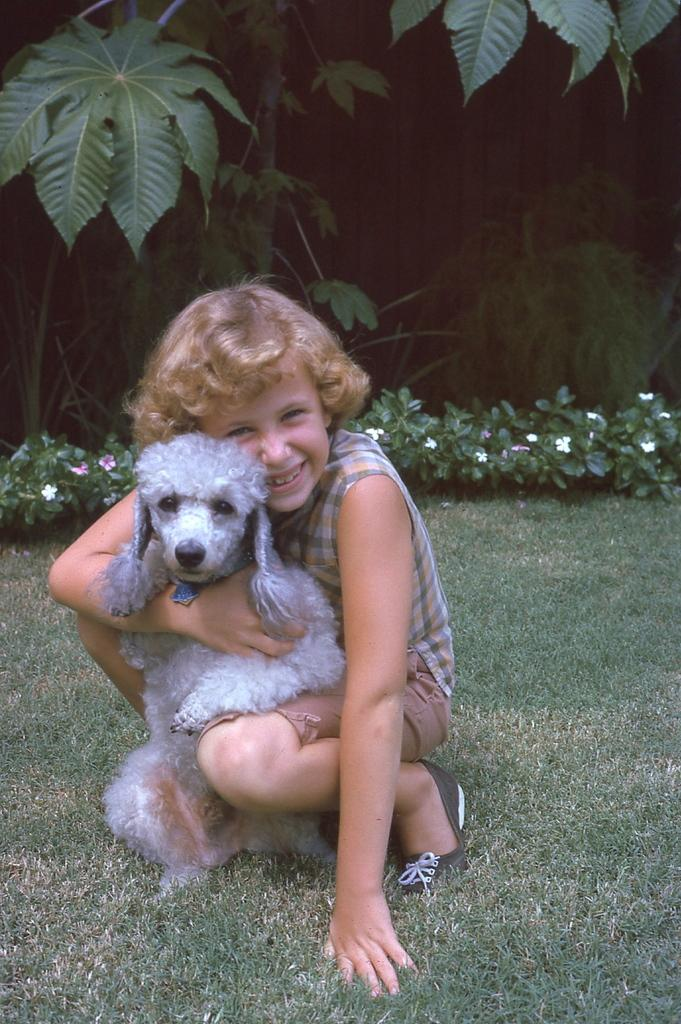What type of plants can be seen in the background of the image? There are flower plants in the background of the image. What is the ground covered with in the image? The area has grass. Who is present in the image? There is a girl in the image. What is the girl holding in the image? The girl is holding a dog with her hand. What type of hat is the girl wearing in the image? There is no hat present in the image; the girl is holding a dog with her hand. What is the girl's income in the image? The girl's income is not mentioned or depicted in the image. 